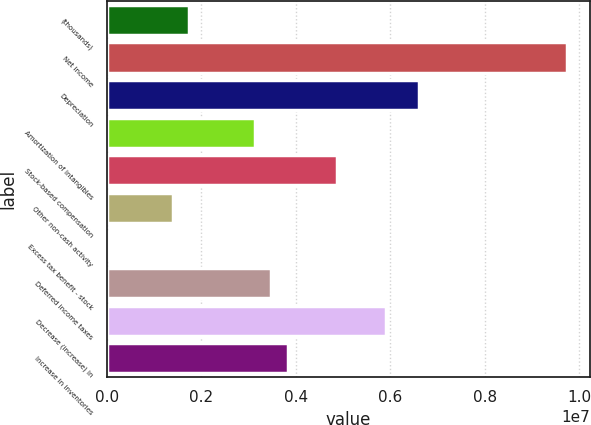Convert chart to OTSL. <chart><loc_0><loc_0><loc_500><loc_500><bar_chart><fcel>(thousands)<fcel>Net income<fcel>Depreciation<fcel>Amortization of intangibles<fcel>Stock-based compensation<fcel>Other non-cash activity<fcel>Excess tax benefit - stock<fcel>Deferred income taxes<fcel>Decrease (increase) in<fcel>Increase in inventories<nl><fcel>1.73917e+06<fcel>9.7379e+06<fcel>6.60796e+06<fcel>3.13025e+06<fcel>4.86911e+06<fcel>1.3914e+06<fcel>317<fcel>3.47802e+06<fcel>5.91242e+06<fcel>3.8258e+06<nl></chart> 